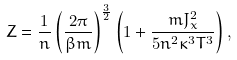<formula> <loc_0><loc_0><loc_500><loc_500>Z = \frac { 1 } { n } \left ( \frac { 2 \pi } { \beta m } \right ) ^ { \frac { 3 } { 2 } } \left ( 1 + \frac { m J _ { x } ^ { 2 } } { 5 n ^ { 2 } \kappa ^ { 3 } T ^ { 3 } } \right ) ,</formula> 